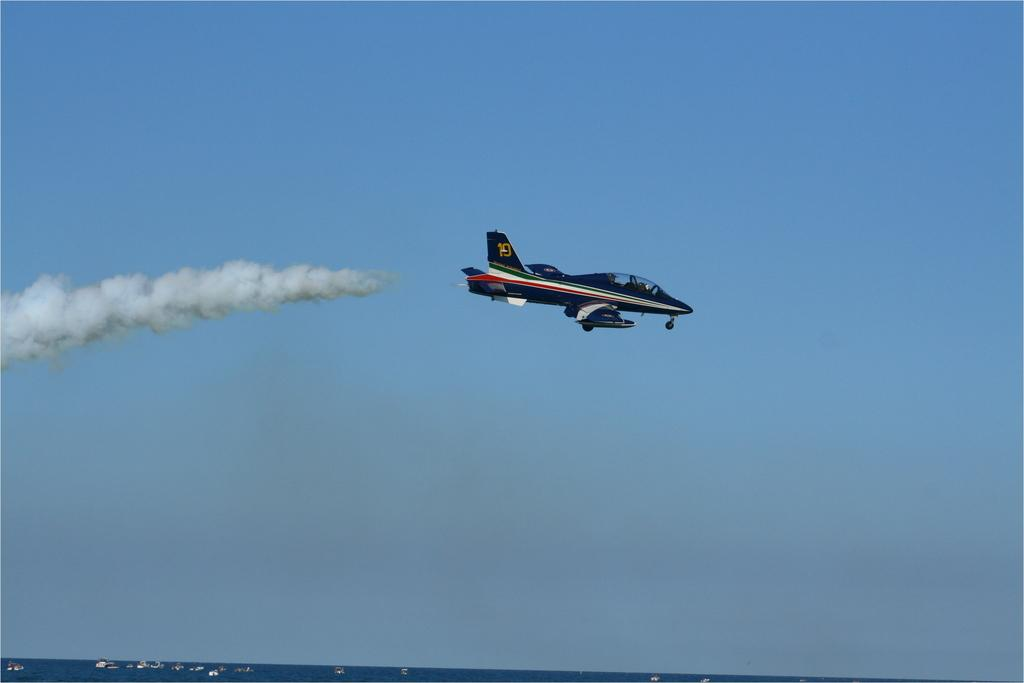<image>
Write a terse but informative summary of the picture. An airplane has the number 10 on its tail. 